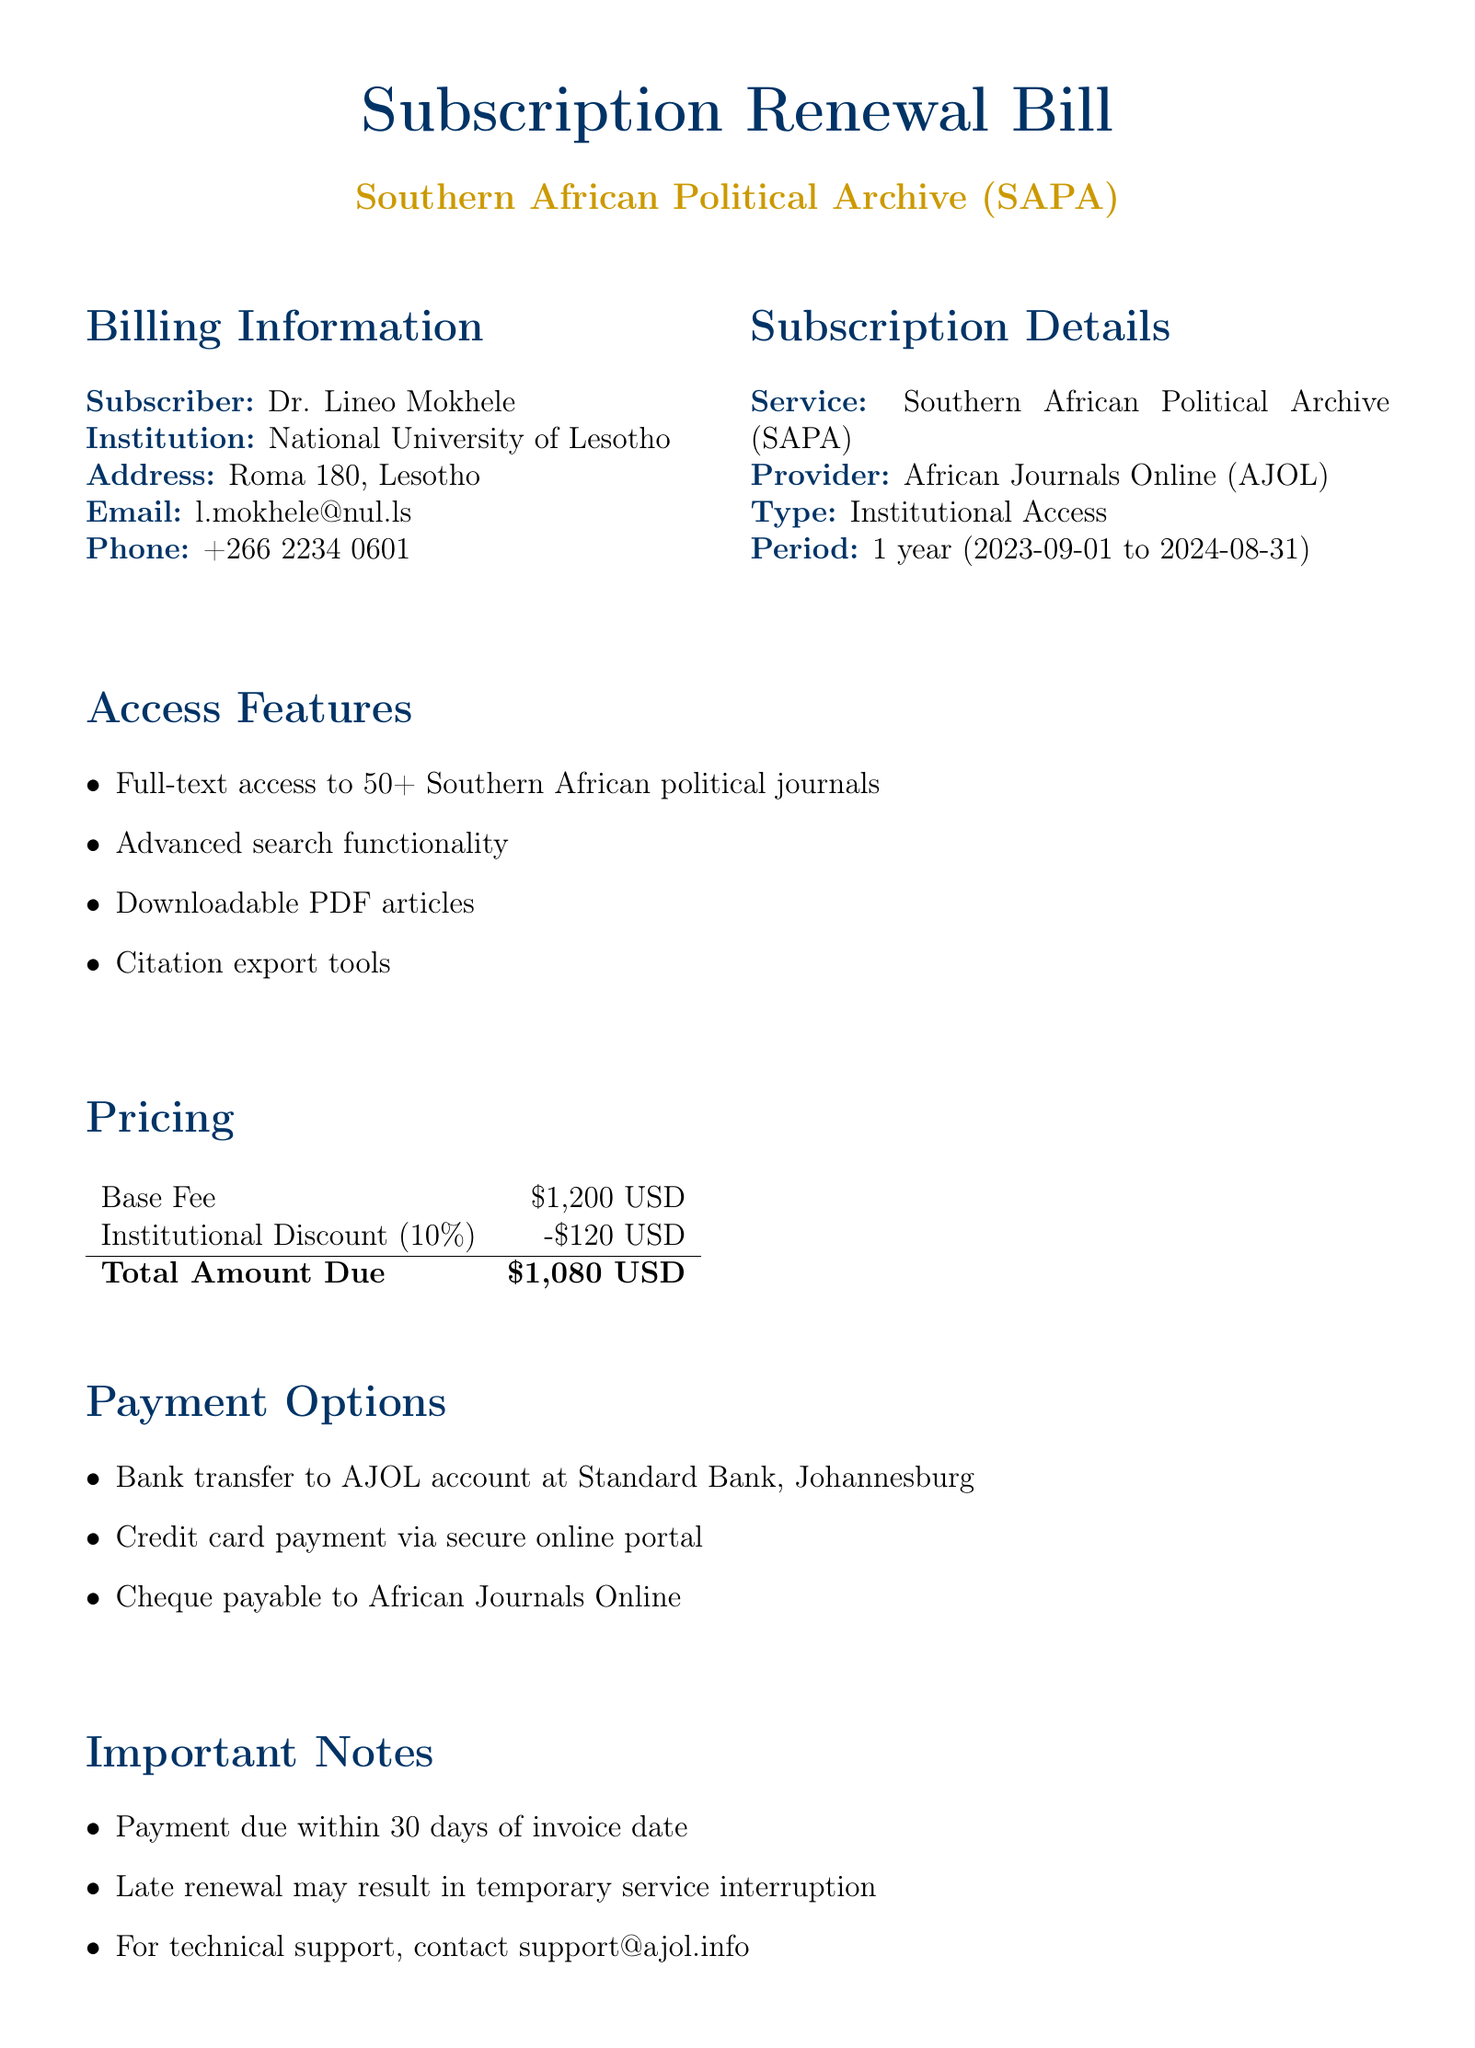What is the subscriber's name? The subscriber's name is provided under the billing information section.
Answer: Dr. Lineo Mokhele What is the total amount due? The total amount due is calculated based on the base fee and the institutional discount mentioned in the pricing section.
Answer: $1,080 USD What is the period of the subscription? The subscription period is specified in the subscription details section.
Answer: 1 year (2023-09-01 to 2024-08-31) Which bank is mentioned for payment transfer? The document specifies the bank to be used for the bank transfer payment option.
Answer: Standard Bank, Johannesburg What percentage is the institutional discount? The institutional discount percentage is mentioned in the pricing section.
Answer: 10% What type of access is provided? The type of access for this subscription is outlined in the subscription details section.
Answer: Institutional Access What is one of the featured journals? A list of featured journals is provided, requiring selection of any one from that list.
Answer: South African Journal of International Affairs How long does the subscriber have to make a payment? The payment timeline is noted in the important notes section regarding the due date for payment.
Answer: 30 days 